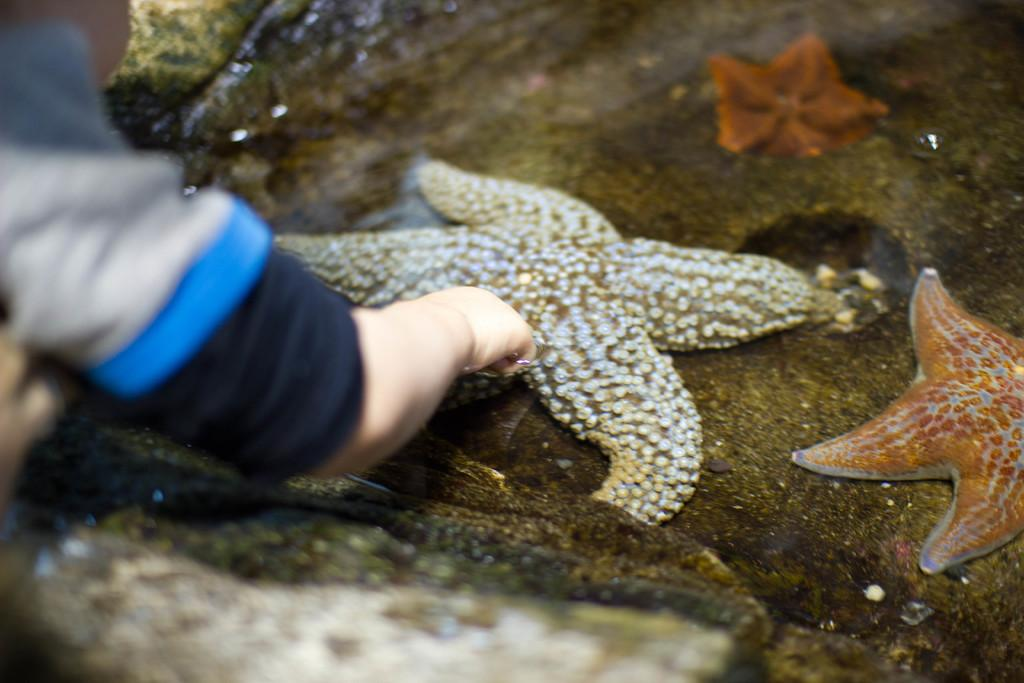What is located on the right side of the image? There is a starfish in the water on the right side of the image. Where is the person's hand in the image? The person's hand is on the left side of the image. What is the person's hand doing in the image? The person's hand appears to be touching the starfish. What type of machine is being used for lunch in the image? There is no machine or lunch present in the image; it features a starfish and a person's hand. 